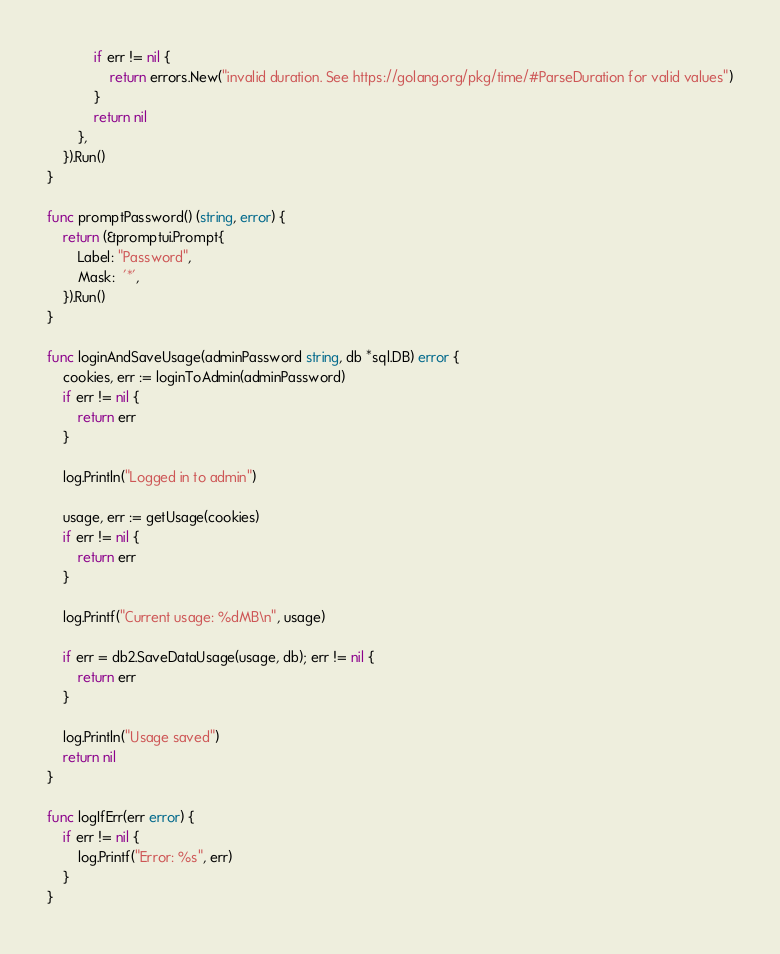<code> <loc_0><loc_0><loc_500><loc_500><_Go_>			if err != nil {
				return errors.New("invalid duration. See https://golang.org/pkg/time/#ParseDuration for valid values")
			}
			return nil
		},
	}).Run()
}

func promptPassword() (string, error) {
	return (&promptui.Prompt{
		Label: "Password",
		Mask:  '*',
	}).Run()
}

func loginAndSaveUsage(adminPassword string, db *sql.DB) error {
	cookies, err := loginToAdmin(adminPassword)
	if err != nil {
		return err
	}

	log.Println("Logged in to admin")

	usage, err := getUsage(cookies)
	if err != nil {
		return err
	}

	log.Printf("Current usage: %dMB\n", usage)

	if err = db2.SaveDataUsage(usage, db); err != nil {
		return err
	}

	log.Println("Usage saved")
	return nil
}

func logIfErr(err error) {
	if err != nil {
		log.Printf("Error: %s", err)
	}
}
</code> 